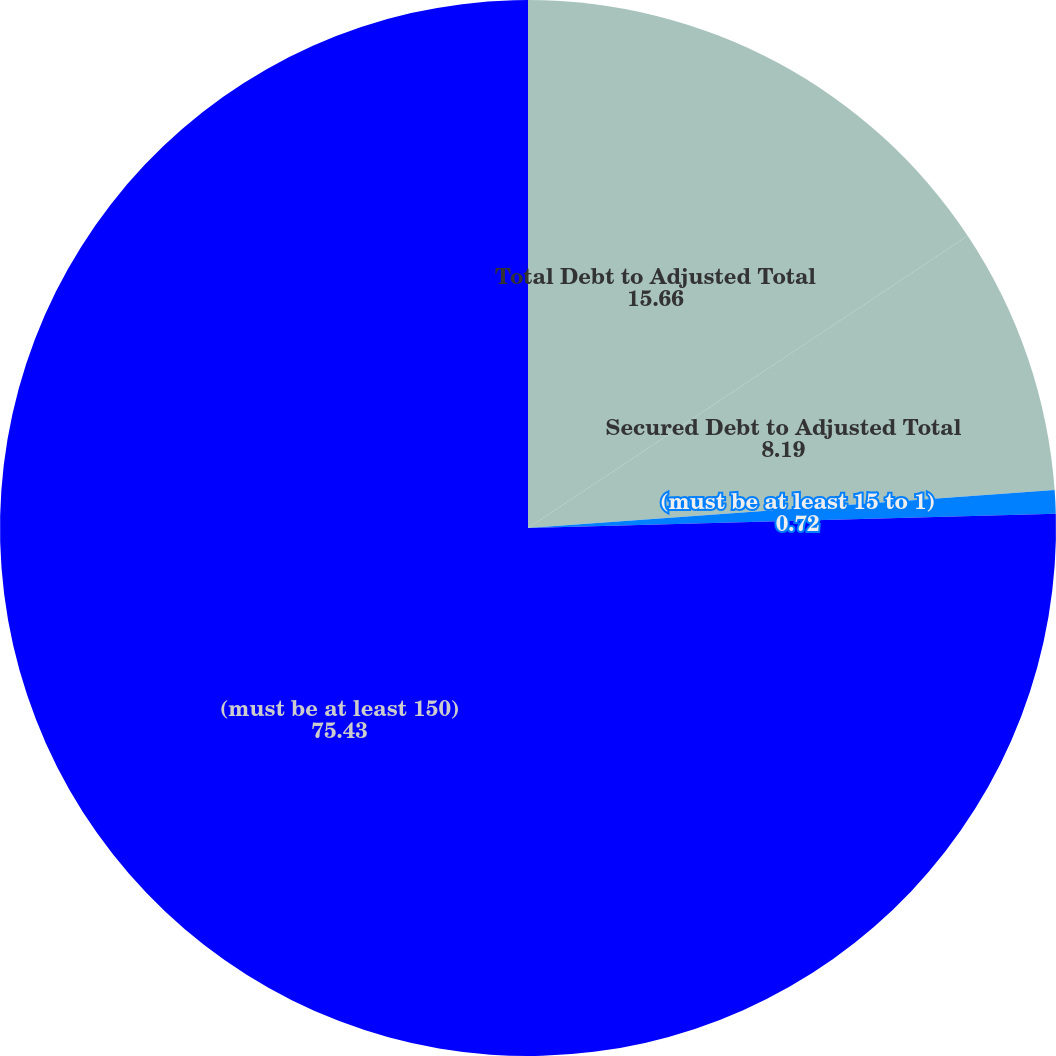<chart> <loc_0><loc_0><loc_500><loc_500><pie_chart><fcel>Total Debt to Adjusted Total<fcel>Secured Debt to Adjusted Total<fcel>(must be at least 15 to 1)<fcel>(must be at least 150)<nl><fcel>15.66%<fcel>8.19%<fcel>0.72%<fcel>75.43%<nl></chart> 